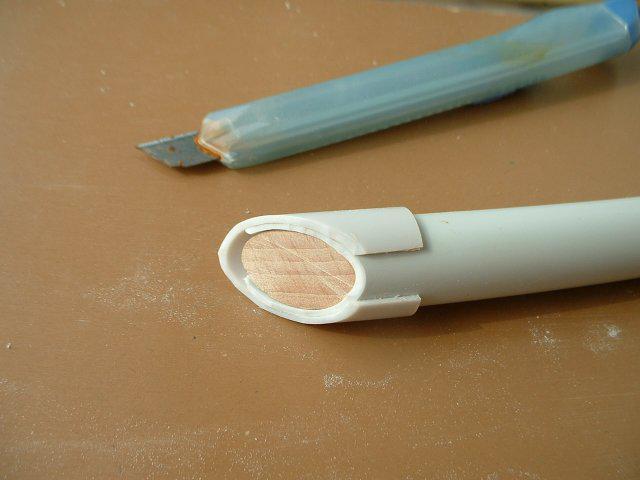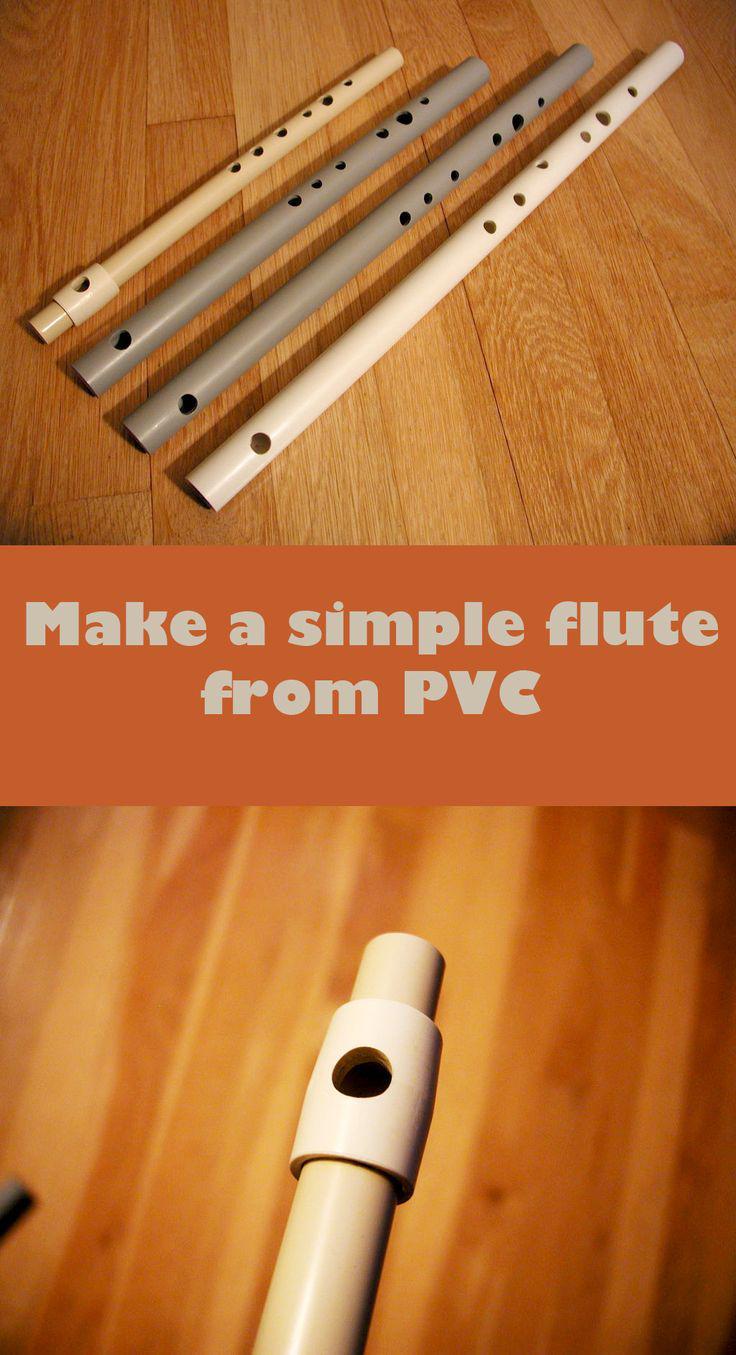The first image is the image on the left, the second image is the image on the right. Assess this claim about the two images: "A sharp object sits near a pipe in the image on the left.". Correct or not? Answer yes or no. Yes. The first image is the image on the left, the second image is the image on the right. Analyze the images presented: Is the assertion "The left image shows a white PVC-look tube with a cut part and a metal-bladed tool near it." valid? Answer yes or no. Yes. 